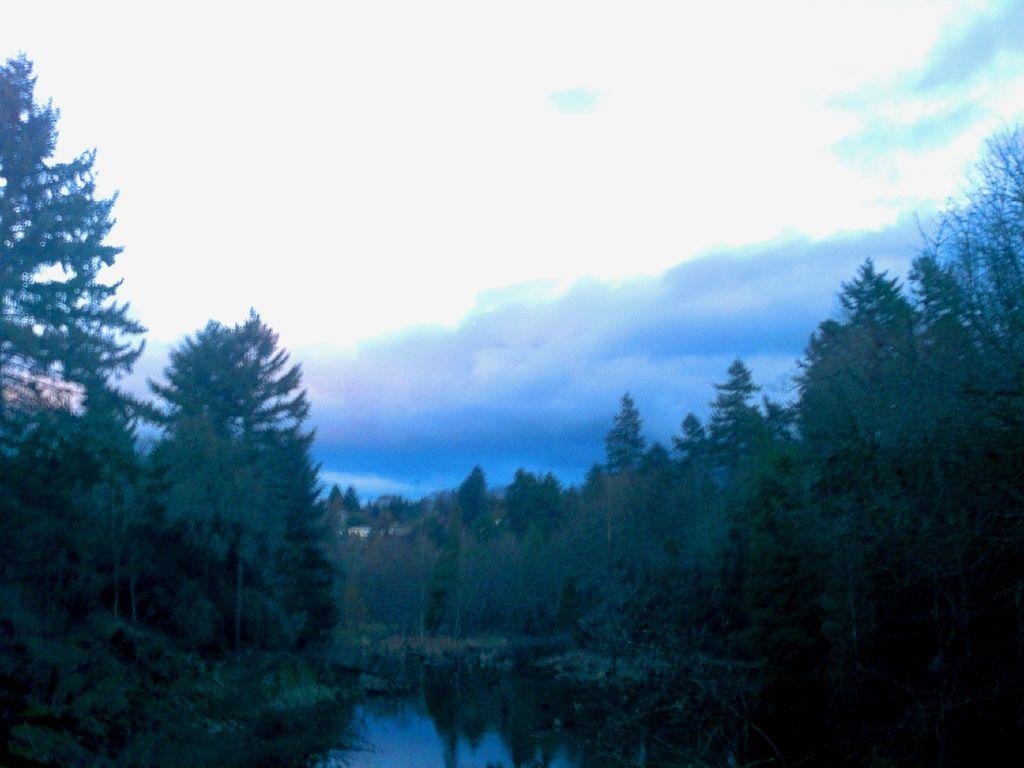What is the primary element visible in the image? There is water in the image. What type of vegetation can be seen in the image? Grass, plants, and trees are visible in the image. What is visible in the sky in the image? Clouds are visible in the sky. What type of knowledge is the bottle containing in the image? There is no bottle present in the image, so it cannot be determined what knowledge it might contain. 